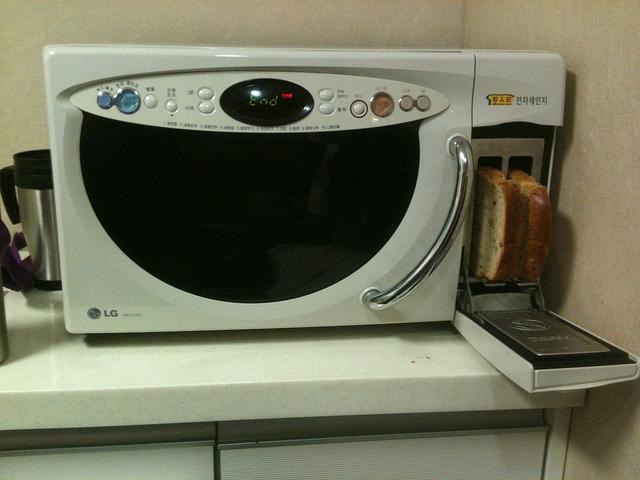Is this toast done?
Answer briefly. No. What's the bread in there for?
Short answer required. Toasting. Would this item be found in a kitchen?
Be succinct. Yes. 